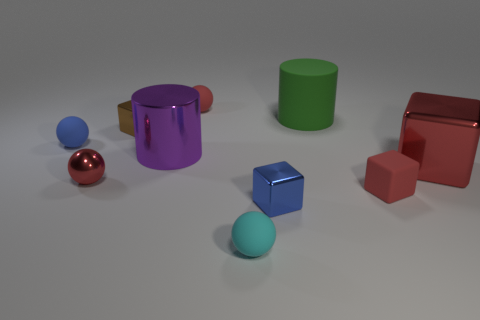Is there a tiny block that has the same color as the big metal cube? Yes, there is a small block that appears to share the same deep blue color as the larger metal cube situated to its right. 